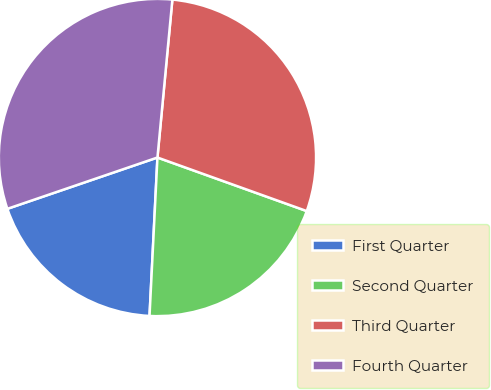Convert chart to OTSL. <chart><loc_0><loc_0><loc_500><loc_500><pie_chart><fcel>First Quarter<fcel>Second Quarter<fcel>Third Quarter<fcel>Fourth Quarter<nl><fcel>18.96%<fcel>20.31%<fcel>28.98%<fcel>31.74%<nl></chart> 